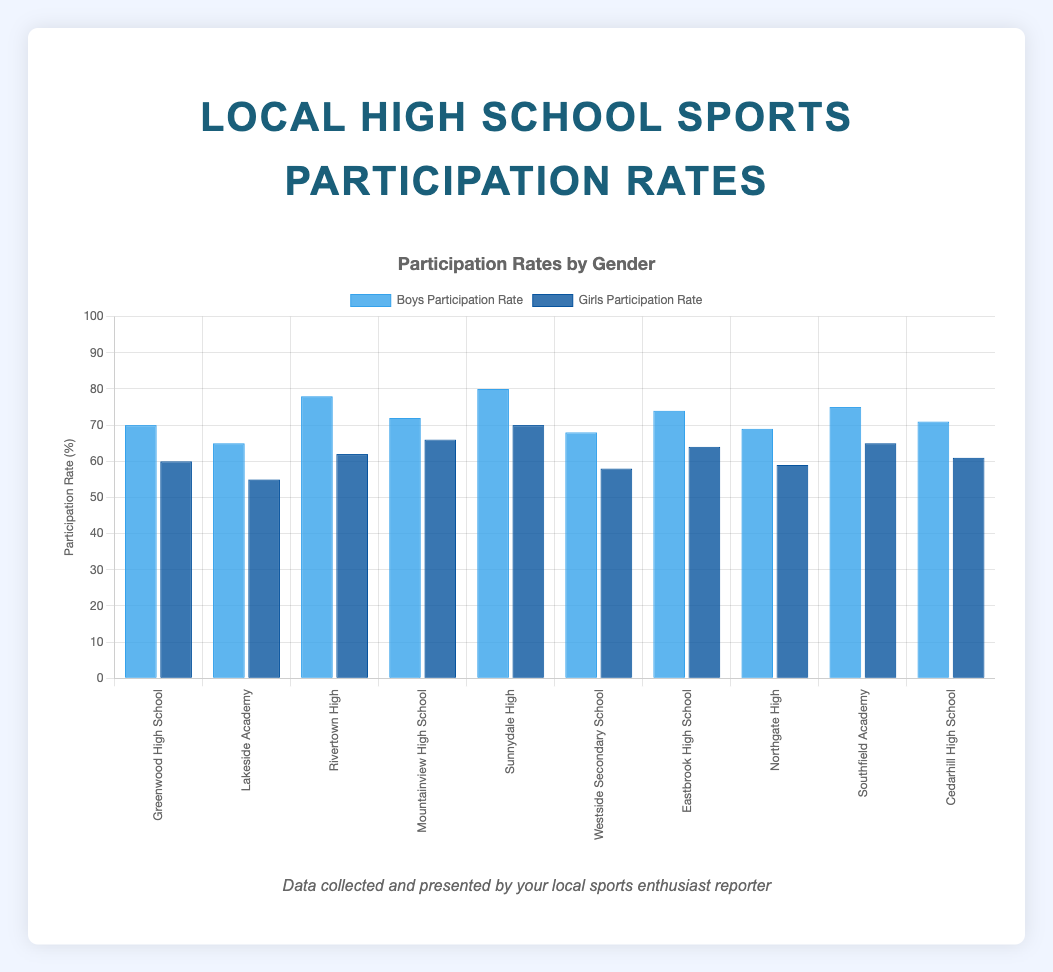What's the average participation rate for boys across all schools? Sum all the boys' participation rates (70 + 65 + 78 + 72 + 80 + 68 + 74 + 69 + 75 + 71) = 722. Divide this by the number of schools (10), so the average boys' participation rate is 722/10 = 72.2.
Answer: 72.2 Which school has the highest girls' participation rate? Look at the height of the dark blue bars representing the girls' participation rates. The tallest dark blue bar is Sunnydale High with a rate of 70%.
Answer: Sunnydale High What is the difference in participation rates between boys and girls at Rivertown High? The boys' participation rate at Rivertown High is 78%, and the girls' rate is 62%. Subtract the girls' rate from the boys' rate: 78 - 62 = 16.
Answer: 16 Which school has the smallest gap between boys' and girls' participation rates? Calculate the differences for all schools and identify the smallest difference: 
Greenwood High: 70 - 60 = 10; 
Lakeside Academy: 65 - 55 = 10; 
Rivertown High: 78 - 62 = 16; 
Mountainview High: 72 - 66 = 6; 
Sunnydale High: 80 - 70 = 10; 
Westside Secondary: 68 - 58 = 10; 
Eastbrook High: 74 - 64 = 10; 
Northgate High: 69 - 59 = 10; 
Southfield Academy: 75 - 65 = 10; 
Cedarhill High: 71 - 61 = 10. The smallest gap is at Mountainview High with 6.
Answer: Mountainview High What is the median participation rate for girls across all schools? Arrange the girls' participation rates in ascending order: 55, 58, 59, 60, 61, 62, 64, 65, 66, 70. Since there are 10 data points, the median will be the average of the 5th and 6th values: (61 + 62) / 2 = 61.5.
Answer: 61.5 Which school has the lowest boys' participation rate? The shortest bar for boys' participation rates is for Lakeside Academy with a rate of 65%.
Answer: Lakeside Academy What's the total participation rate (boys + girls) for Eastbrook High School? Add the boys' and girls' participation rates for Eastbrook High: 74% + 64% = 138%.
Answer: 138 How many schools have a girls' participation rate above 60%? Count the schools where the height of the dark blue bar is above the 60% mark. The schools are Mountainview High (66), Sunnydale High (70), Eastbrook High (64), Southfield Academy (65), and Cedarhill High (61). There are 5 such schools.
Answer: 5 What's the average participation rate for girls across all schools? Sum all the girls' participation rates (60 + 55 + 62 + 66 + 70 + 58 + 64 + 59 + 65 + 61) = 620. Divide this by the number of schools (10), so the average girls' participation rate is 620/10 = 62.
Answer: 62 